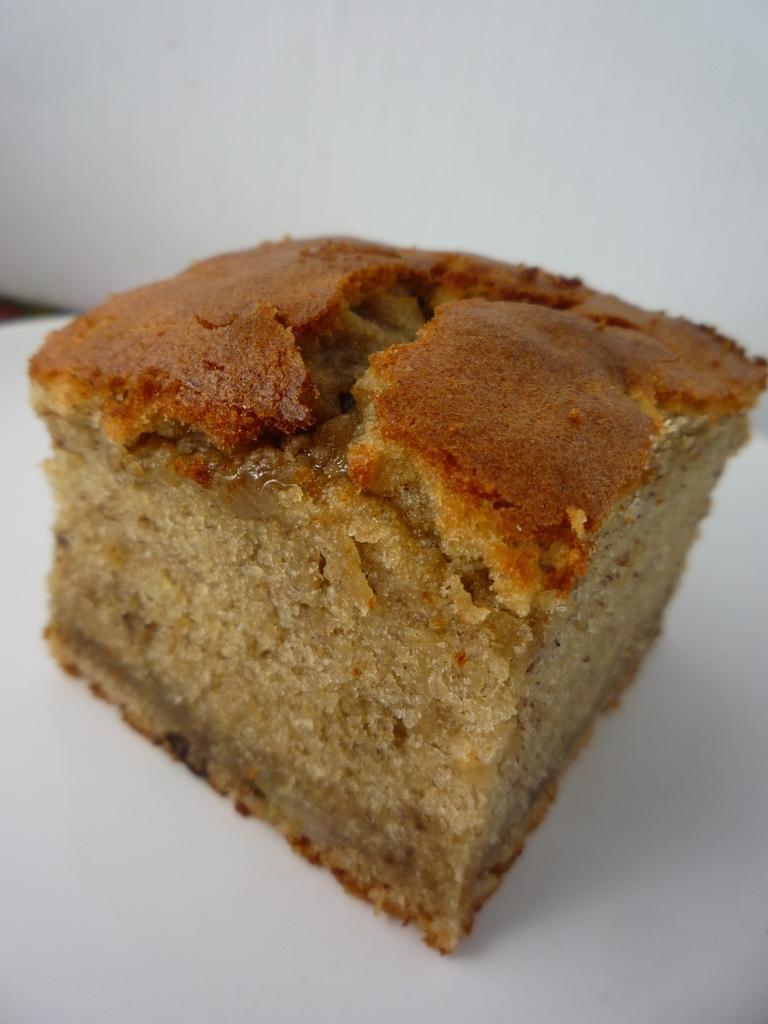In one or two sentences, can you explain what this image depicts? In the foreground of this image, there is a cake on a platter and in the background, there is a white wall. 